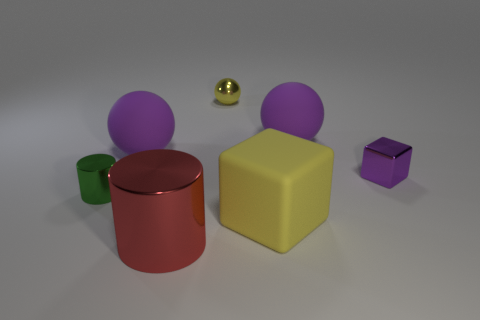Can you describe the colors displayed in the objects? Certainly! There's a diversity of colors among the objects: we see purple, green, red, yellow, and a smaller object with what appears to be a metallic gold finish. 